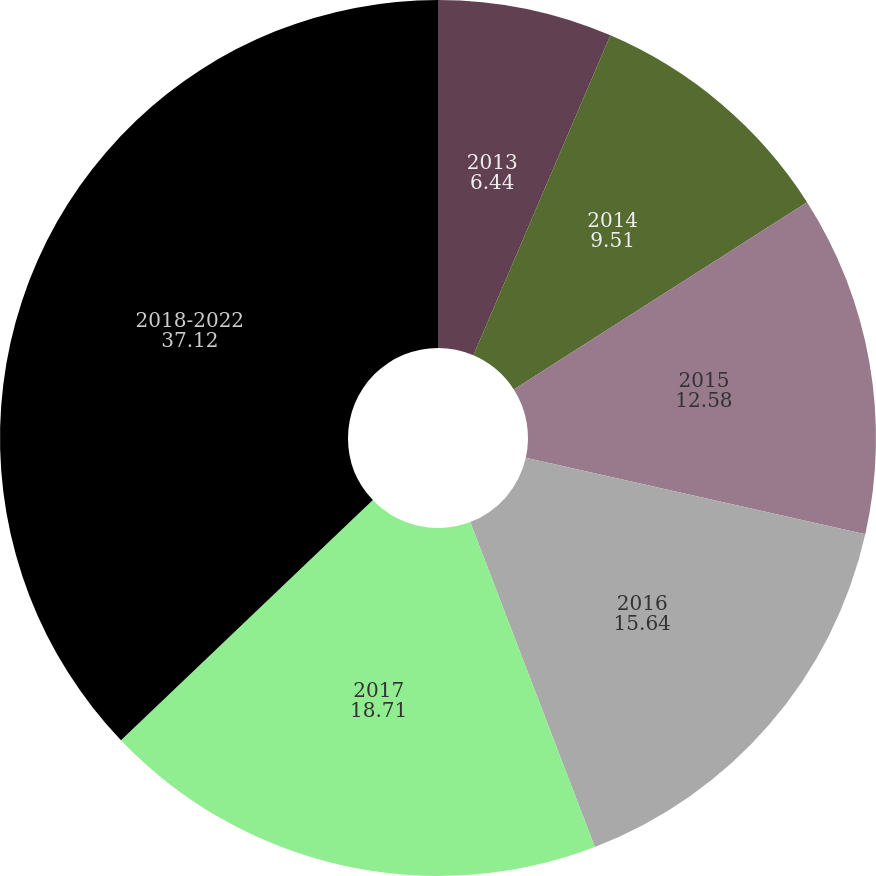<chart> <loc_0><loc_0><loc_500><loc_500><pie_chart><fcel>2013<fcel>2014<fcel>2015<fcel>2016<fcel>2017<fcel>2018-2022<nl><fcel>6.44%<fcel>9.51%<fcel>12.58%<fcel>15.64%<fcel>18.71%<fcel>37.12%<nl></chart> 